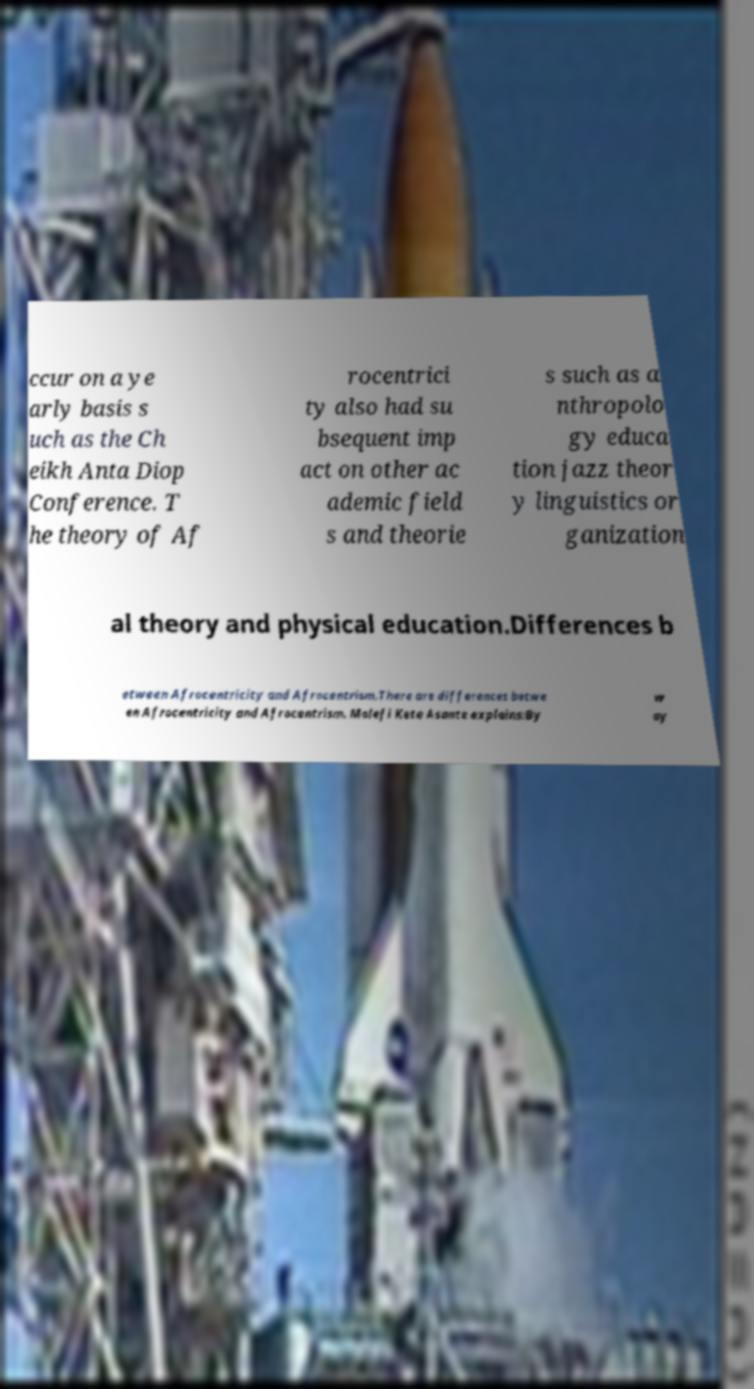Could you assist in decoding the text presented in this image and type it out clearly? ccur on a ye arly basis s uch as the Ch eikh Anta Diop Conference. T he theory of Af rocentrici ty also had su bsequent imp act on other ac ademic field s and theorie s such as a nthropolo gy educa tion jazz theor y linguistics or ganization al theory and physical education.Differences b etween Afrocentricity and Afrocentrism.There are differences betwe en Afrocentricity and Afrocentrism. Molefi Kete Asante explains:By w ay 